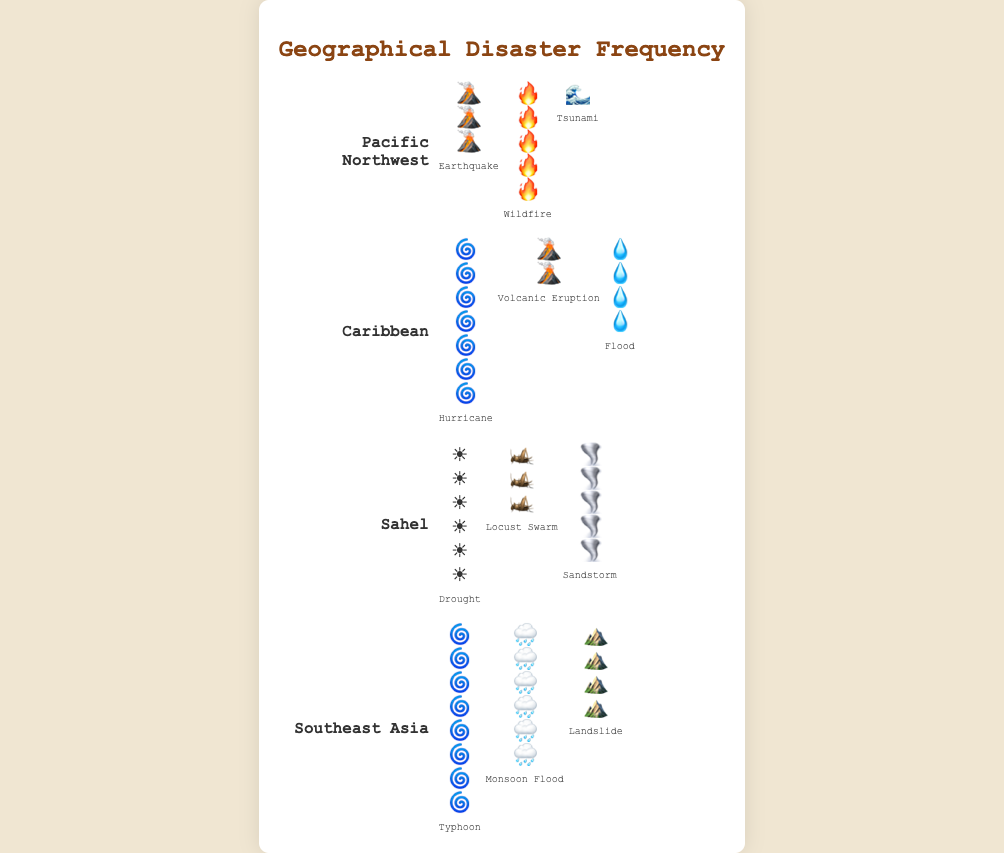How many types of natural disasters are listed for the Pacific Northwest region? There are three types of natural disasters listed for the Pacific Northwest region: Earthquake, Wildfire, and Tsunami. This can be observed from the figures representing each type.
Answer: 3 Which natural disaster has the highest frequency in the Caribbean region? The natural disaster with the highest frequency in the Caribbean is Hurricane, represented by seven icons.
Answer: Hurricane What is the total frequency of all natural disasters in the Sahel region? The total frequency is the sum of the frequencies of Drought (6), Locust Swarm (3), and Sandstorm (5). So, 6 + 3 + 5 = 14.
Answer: 14 Is the frequency of Typhoons in Southeast Asia greater than the frequency of Hurricanes in the Caribbean? The frequency of Typhoons in Southeast Asia is represented by eight icons while Hurricanes in the Caribbean are represented by seven icons. Therefore, Typhoons have a greater frequency.
Answer: Yes How many regions experience Earthquakes? Only the Pacific Northwest region has Earthquakes listed as a natural disaster.
Answer: 1 Which type of disaster has a frequency of exactly four in any region? Wildfire in the Pacific Northwest has a frequency of 5. Flood in the Caribbean and Landslides in Southeast Asia each have a frequency of 4.
Answer: Flood, Landslide Which region has the highest total frequency of natural disasters? We need to sum the frequencies for all regions: 
- Pacific Northwest: 3+5+1=9 
- Caribbean: 7+2+4=13 
- Sahel: 6+3+5=14 
- Southeast Asia: 8+6+4=18 
The highest total frequency is in Southeast Asia.
Answer: Southeast Asia What is the difference in frequency between Typhoons and Monsoon Floods in Southeast Asia? The frequency of Typhoons is eight, and the frequency of Monsoon Floods is six. The difference is 8 - 6 = 2.
Answer: 2 Which disaster is unique to only one region and what is its frequency? Tsunami is unique to the Pacific Northwest region, and its frequency is represented by one icon.
Answer: Tsunami, 1 